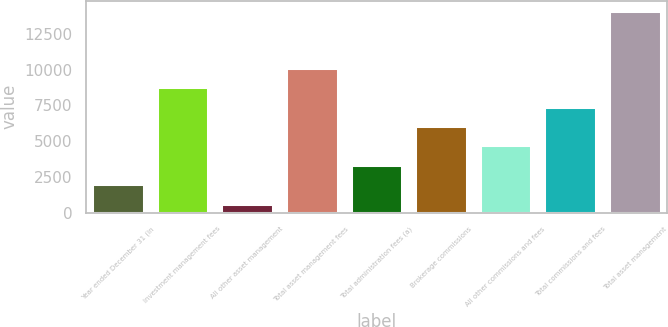Convert chart. <chart><loc_0><loc_0><loc_500><loc_500><bar_chart><fcel>Year ended December 31 (in<fcel>Investment management fees<fcel>All other asset management<fcel>Total asset management fees<fcel>Total administration fees (a)<fcel>Brokerage commissions<fcel>All other commissions and fees<fcel>Total commissions and fees<fcel>Total asset management<nl><fcel>2011<fcel>8755.5<fcel>605<fcel>10104.4<fcel>3359.9<fcel>6057.7<fcel>4708.8<fcel>7406.6<fcel>14094<nl></chart> 